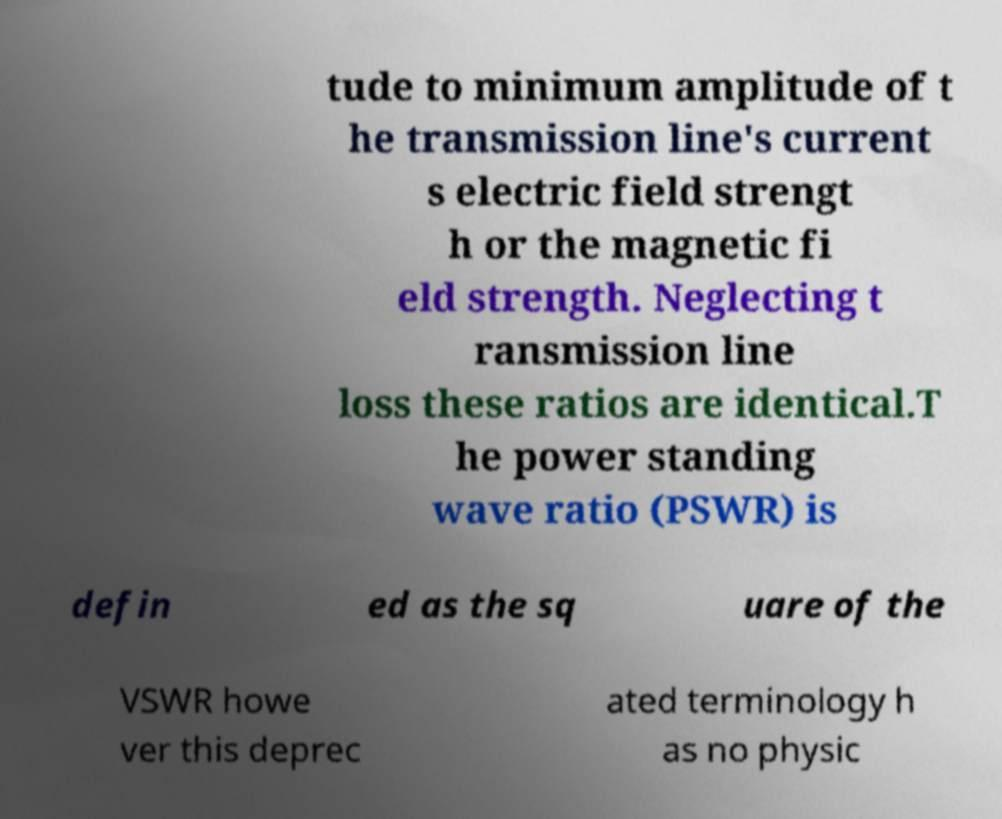There's text embedded in this image that I need extracted. Can you transcribe it verbatim? tude to minimum amplitude of t he transmission line's current s electric field strengt h or the magnetic fi eld strength. Neglecting t ransmission line loss these ratios are identical.T he power standing wave ratio (PSWR) is defin ed as the sq uare of the VSWR howe ver this deprec ated terminology h as no physic 